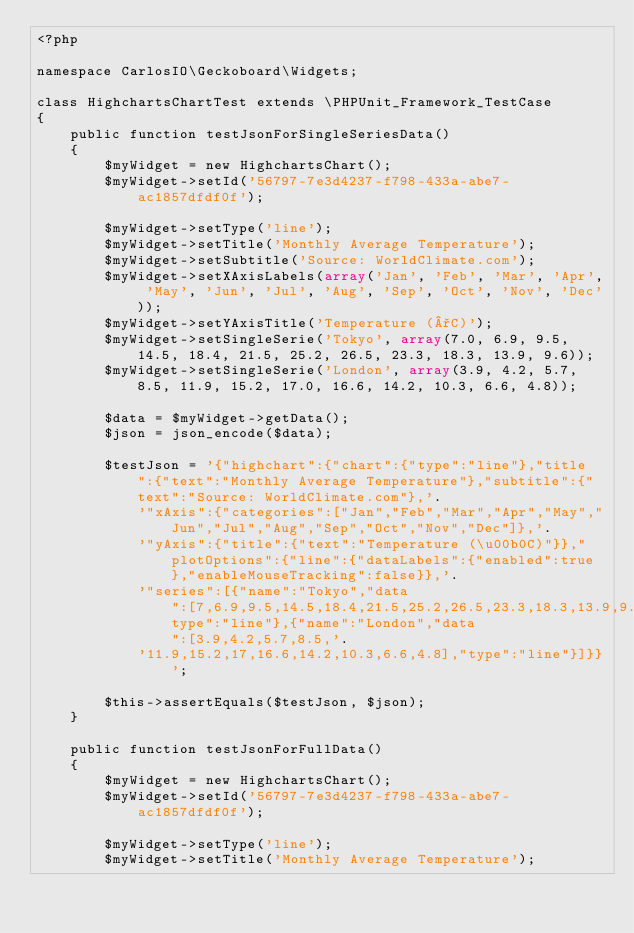Convert code to text. <code><loc_0><loc_0><loc_500><loc_500><_PHP_><?php

namespace CarlosIO\Geckoboard\Widgets;

class HighchartsChartTest extends \PHPUnit_Framework_TestCase
{
    public function testJsonForSingleSeriesData()
    {
        $myWidget = new HighchartsChart();
        $myWidget->setId('56797-7e3d4237-f798-433a-abe7-ac1857dfdf0f');

        $myWidget->setType('line');
        $myWidget->setTitle('Monthly Average Temperature');
        $myWidget->setSubtitle('Source: WorldClimate.com');
        $myWidget->setXAxisLabels(array('Jan', 'Feb', 'Mar', 'Apr', 'May', 'Jun', 'Jul', 'Aug', 'Sep', 'Oct', 'Nov', 'Dec'));
        $myWidget->setYAxisTitle('Temperature (°C)');
        $myWidget->setSingleSerie('Tokyo', array(7.0, 6.9, 9.5, 14.5, 18.4, 21.5, 25.2, 26.5, 23.3, 18.3, 13.9, 9.6));
        $myWidget->setSingleSerie('London', array(3.9, 4.2, 5.7, 8.5, 11.9, 15.2, 17.0, 16.6, 14.2, 10.3, 6.6, 4.8));

        $data = $myWidget->getData();
        $json = json_encode($data);

        $testJson = '{"highchart":{"chart":{"type":"line"},"title":{"text":"Monthly Average Temperature"},"subtitle":{"text":"Source: WorldClimate.com"},'.
            '"xAxis":{"categories":["Jan","Feb","Mar","Apr","May","Jun","Jul","Aug","Sep","Oct","Nov","Dec"]},'.
            '"yAxis":{"title":{"text":"Temperature (\u00b0C)"}},"plotOptions":{"line":{"dataLabels":{"enabled":true},"enableMouseTracking":false}},'.
            '"series":[{"name":"Tokyo","data":[7,6.9,9.5,14.5,18.4,21.5,25.2,26.5,23.3,18.3,13.9,9.6],"type":"line"},{"name":"London","data":[3.9,4.2,5.7,8.5,'.
            '11.9,15.2,17,16.6,14.2,10.3,6.6,4.8],"type":"line"}]}}';

        $this->assertEquals($testJson, $json);
    }

    public function testJsonForFullData()
    {
        $myWidget = new HighchartsChart();
        $myWidget->setId('56797-7e3d4237-f798-433a-abe7-ac1857dfdf0f');

        $myWidget->setType('line');
        $myWidget->setTitle('Monthly Average Temperature');</code> 